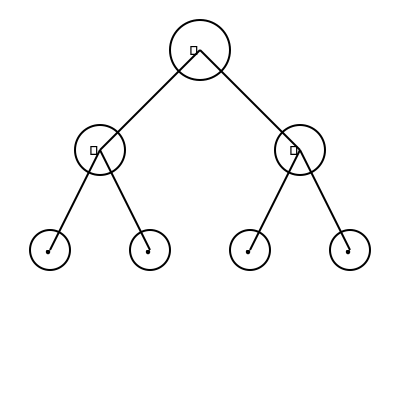In the family tree diagram above, jewelry motifs are used to represent different generations. If the star (★) represents a brooch, the diamond (◆) represents earrings, and the dot (●) represents a ring, calculate the total number of unique jewelry pieces represented across all generations, assuming each symbol represents a pair for earrings. To solve this problem, let's break it down step-by-step:

1. Identify the generations:
   - 1st generation (top): 1 star (★)
   - 2nd generation (middle): 2 diamonds (◆)
   - 3rd generation (bottom): 4 dots (●)

2. Count the unique pieces for each generation:
   - 1st generation: 1 brooch (★)
   - 2nd generation: 1 pair of earrings (◆)
   - 3rd generation: 4 rings (●)

3. Calculate the total number of unique pieces:
   - Brooches: 1
   - Earrings: 1 pair
   - Rings: 4

4. Sum up the total:
   $1 + 1 + 4 = 6$ unique jewelry pieces

Therefore, the total number of unique jewelry pieces represented across all generations is 6.
Answer: 6 unique jewelry pieces 